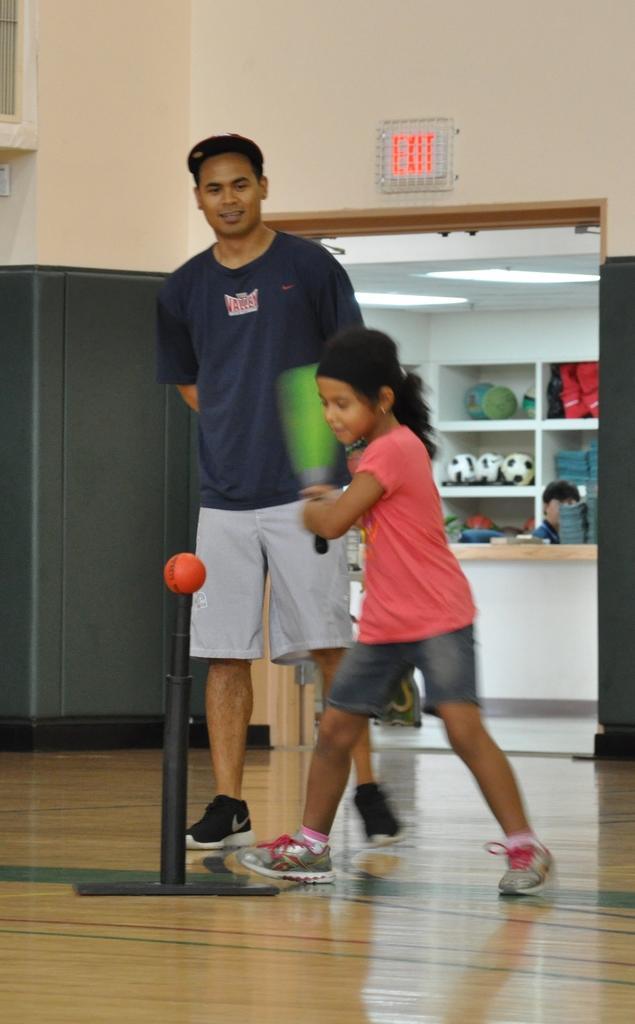Could you give a brief overview of what you see in this image? Here we can see a man and a girl. She is holding a bat with her hand and in a position to hit a ball. This is floor. In the background we can see a cupboard, wall, balls, clothes, and lights. 